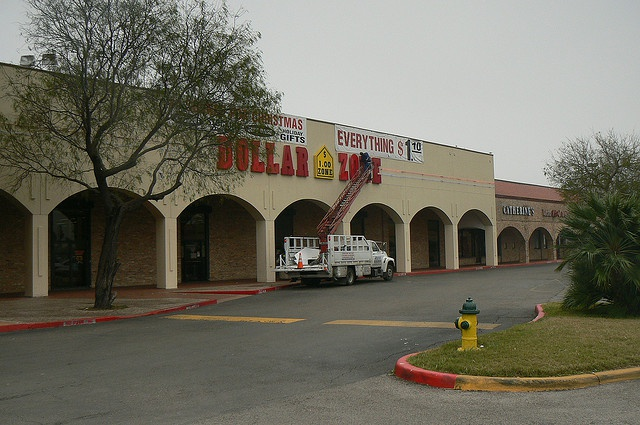Describe the objects in this image and their specific colors. I can see truck in darkgray, black, and gray tones, fire hydrant in darkgray, olive, and black tones, and people in darkgray, black, gray, and navy tones in this image. 